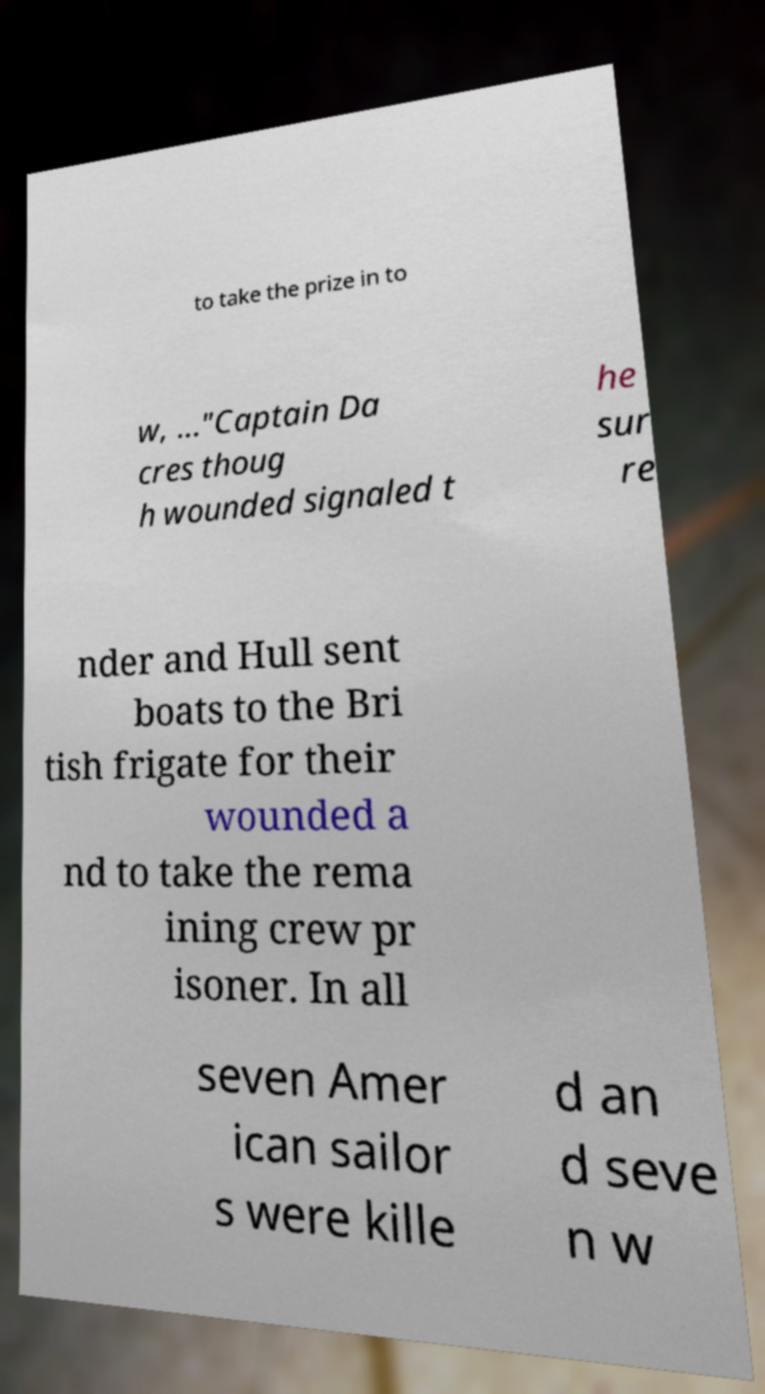Can you accurately transcribe the text from the provided image for me? to take the prize in to w, ..."Captain Da cres thoug h wounded signaled t he sur re nder and Hull sent boats to the Bri tish frigate for their wounded a nd to take the rema ining crew pr isoner. In all seven Amer ican sailor s were kille d an d seve n w 